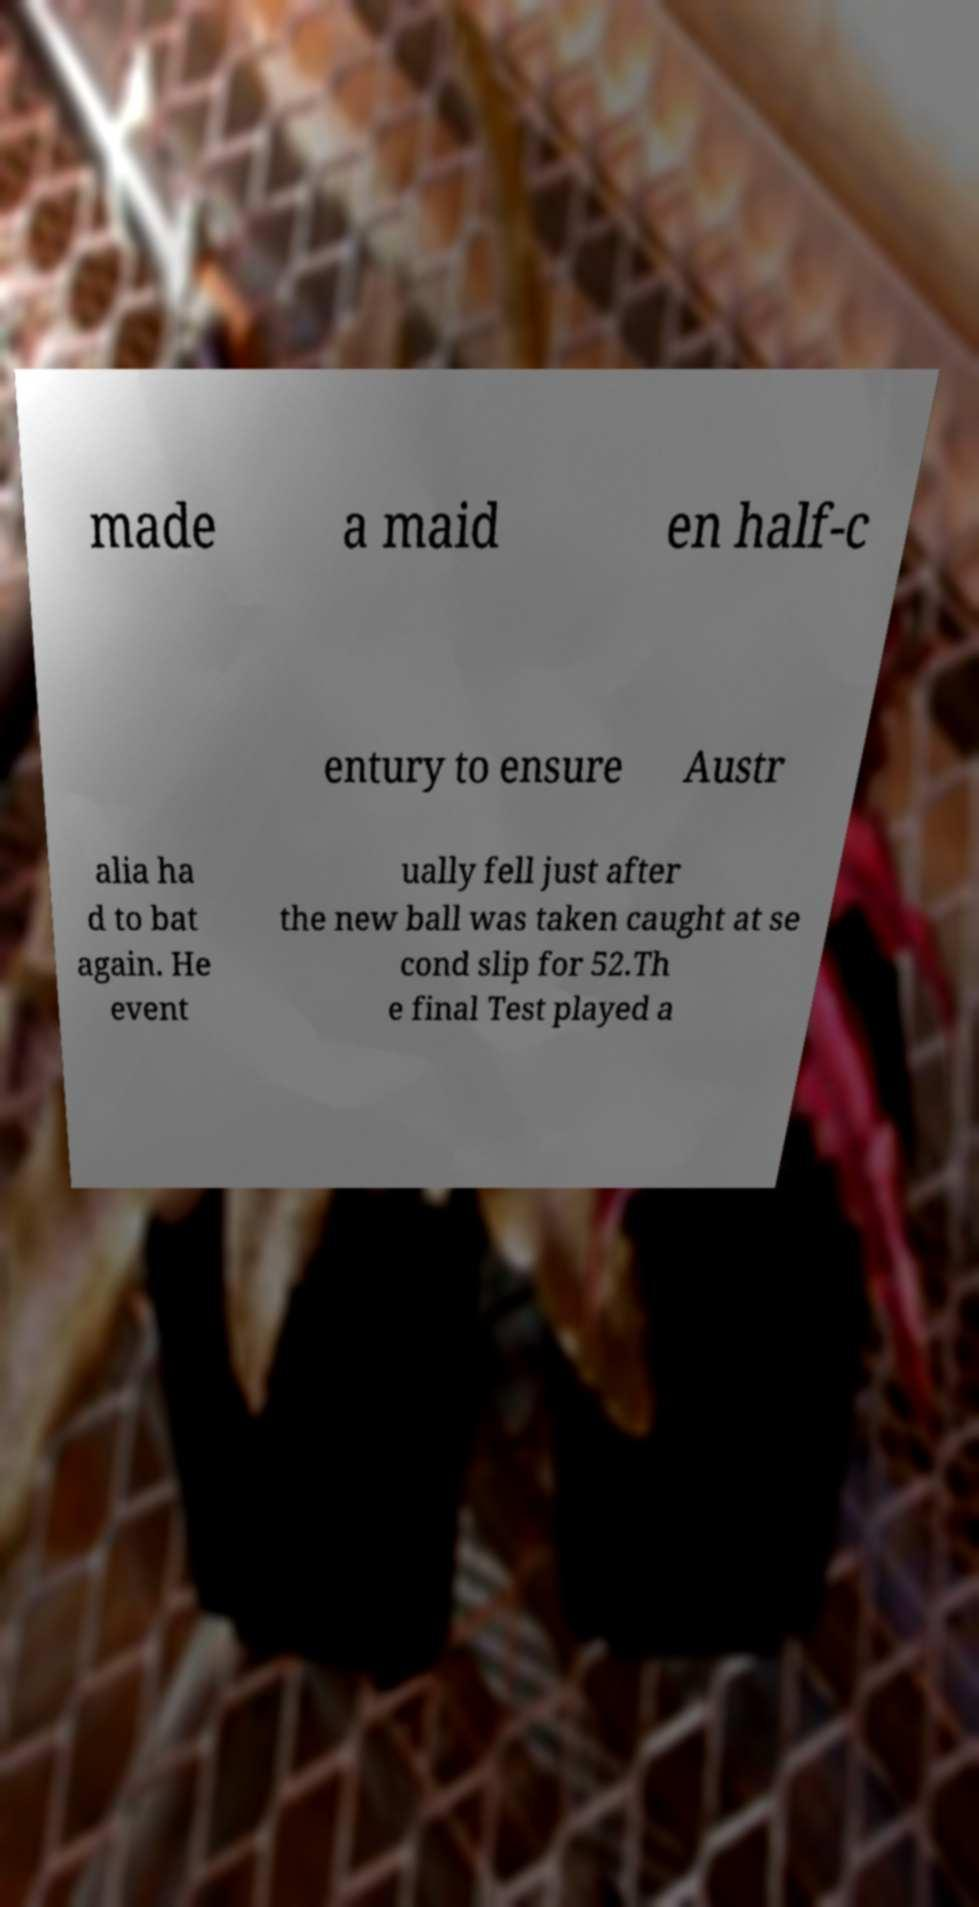I need the written content from this picture converted into text. Can you do that? made a maid en half-c entury to ensure Austr alia ha d to bat again. He event ually fell just after the new ball was taken caught at se cond slip for 52.Th e final Test played a 